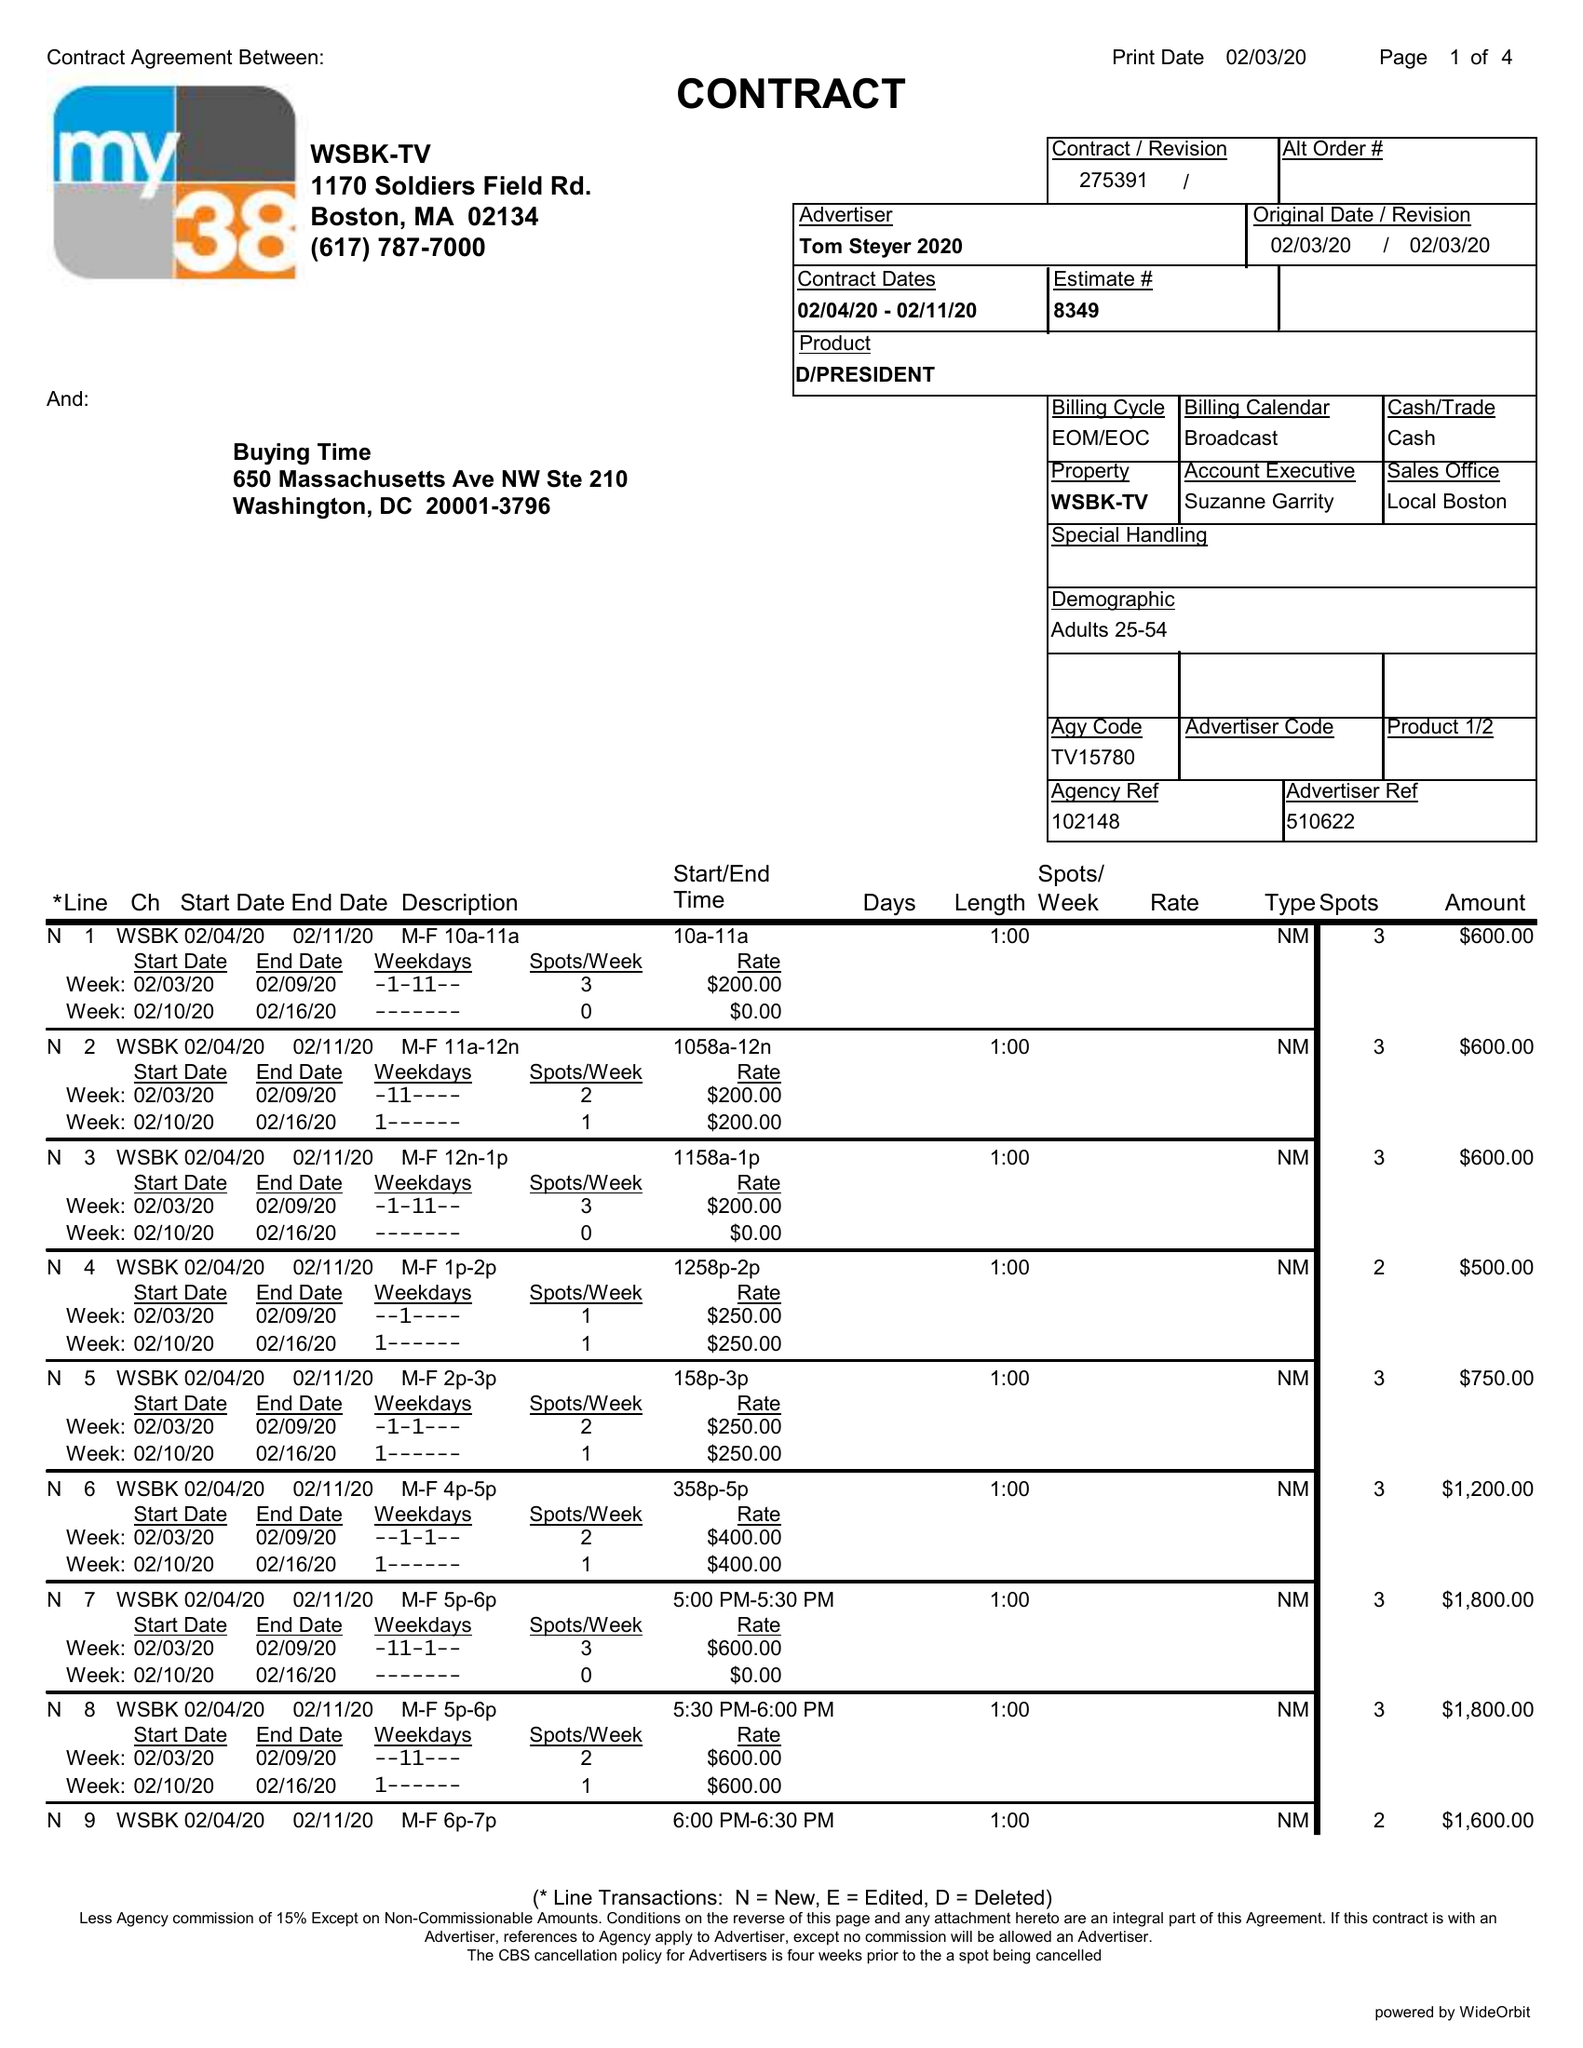What is the value for the contract_num?
Answer the question using a single word or phrase. 275391 